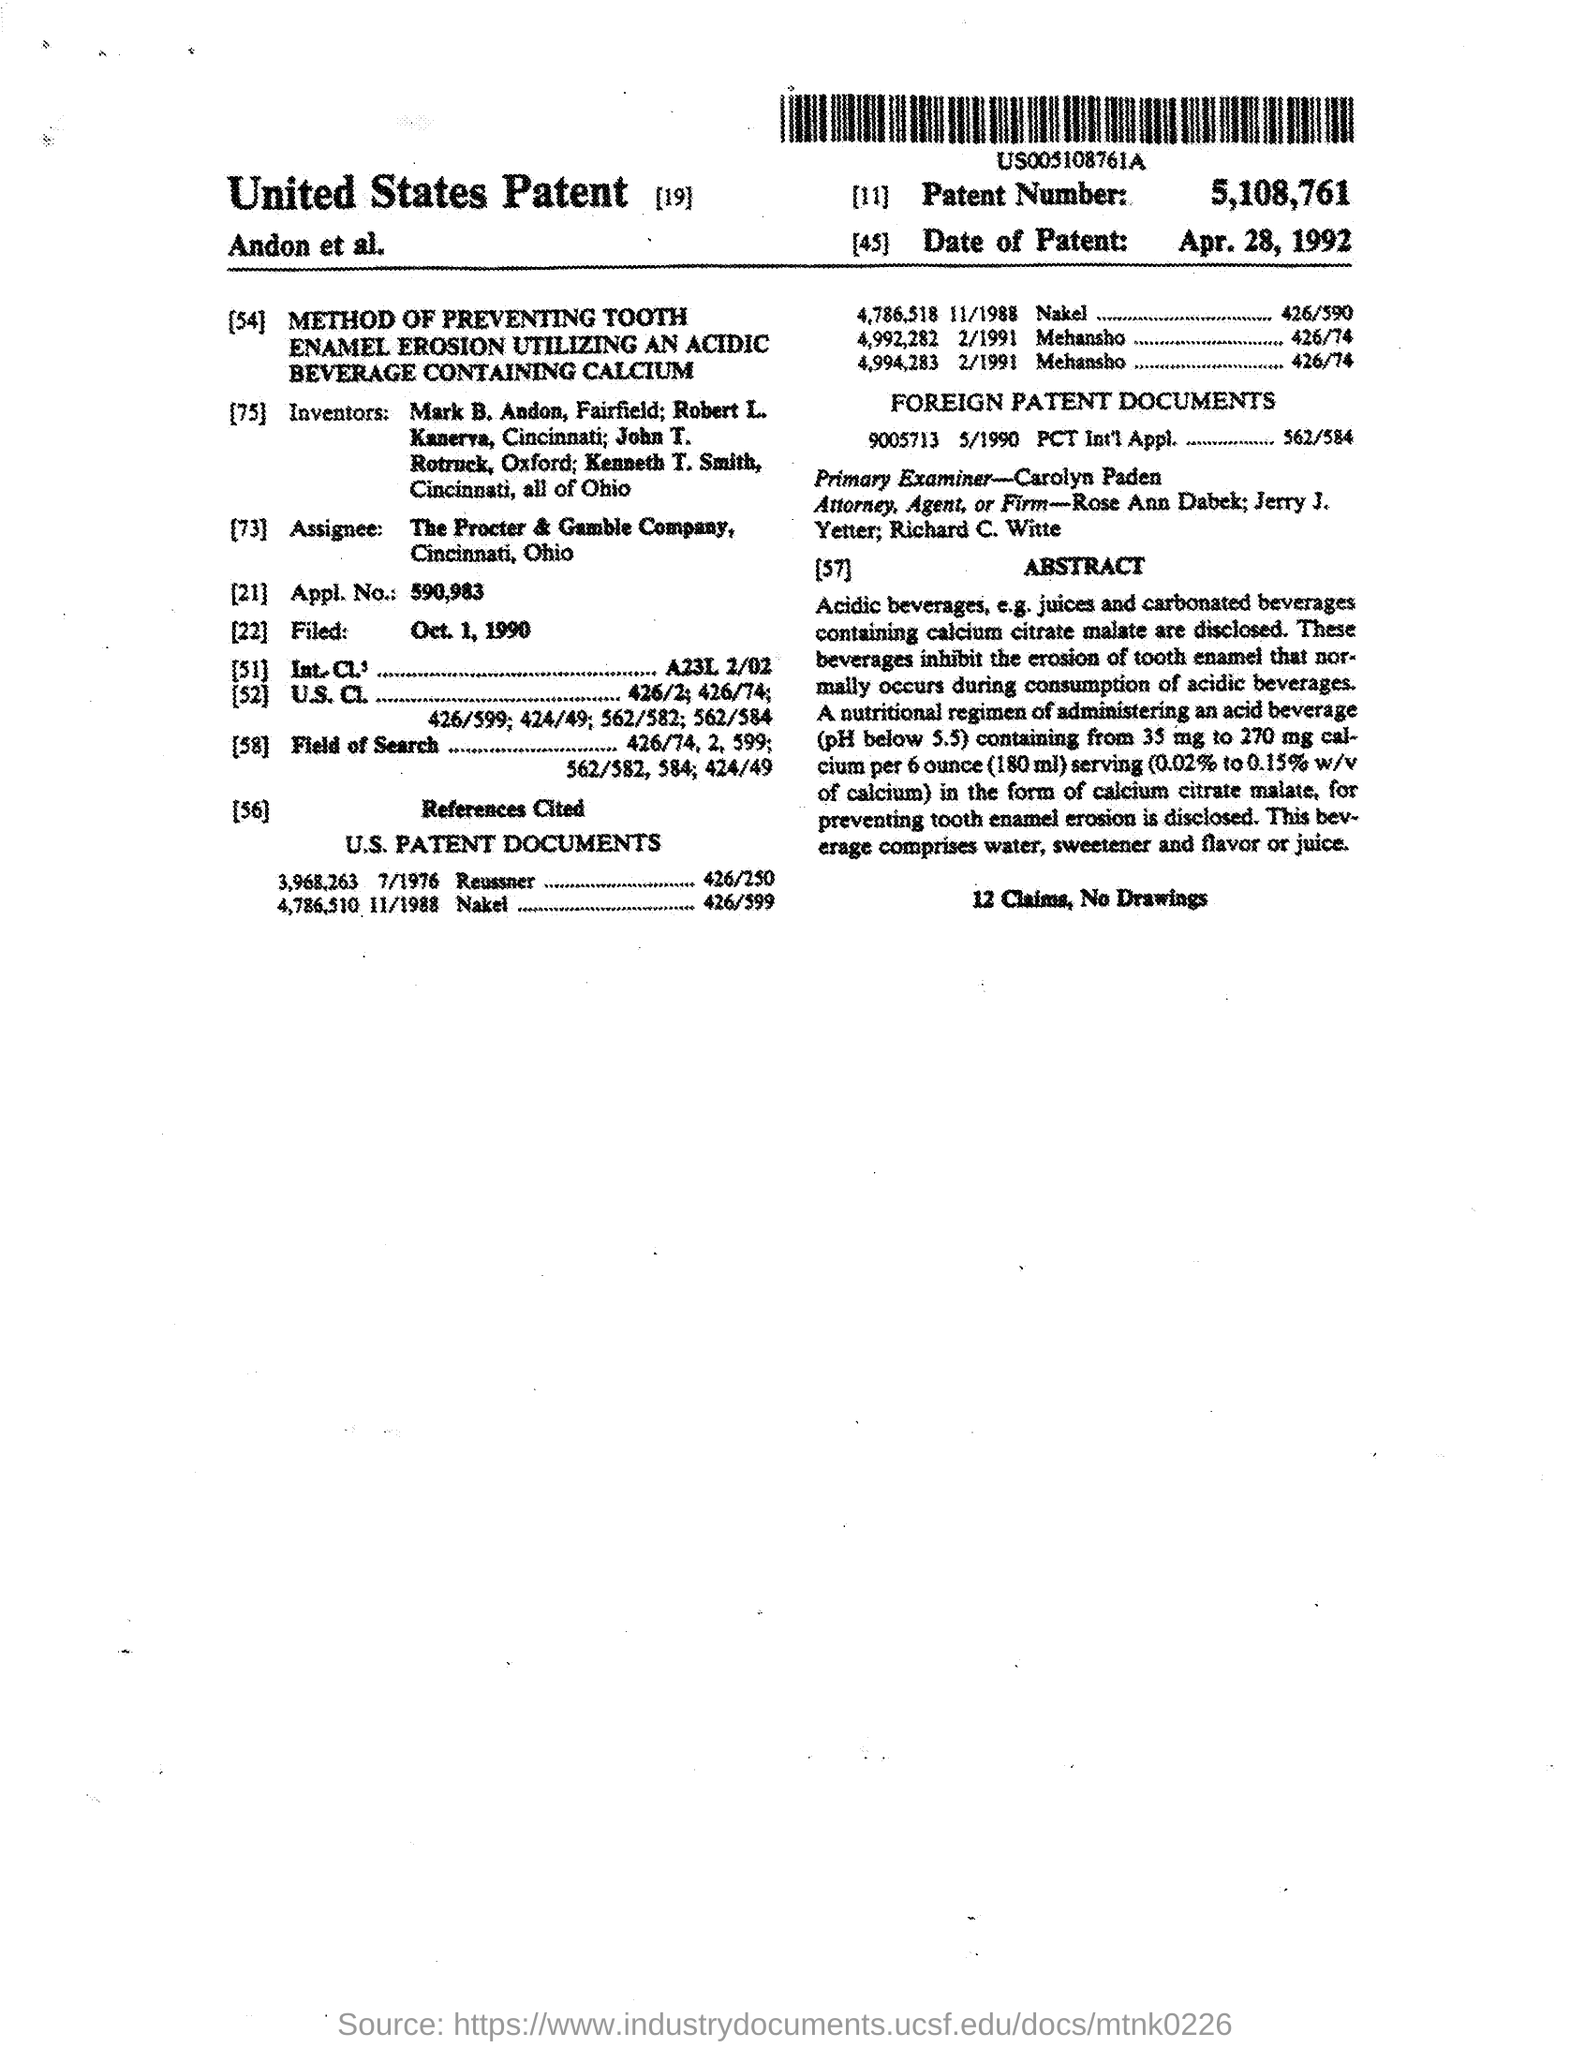Highlight a few significant elements in this photo. The patent number mentioned in the given form is 5,108,761. The date of filed mentioned in the given form is October 1, 1990. The patent mentioned in the given form was filed on April 28, 1992. The primary examiner mentioned in the given form is Carolyn Paden. The application number mentioned in the given form is 590,983. 